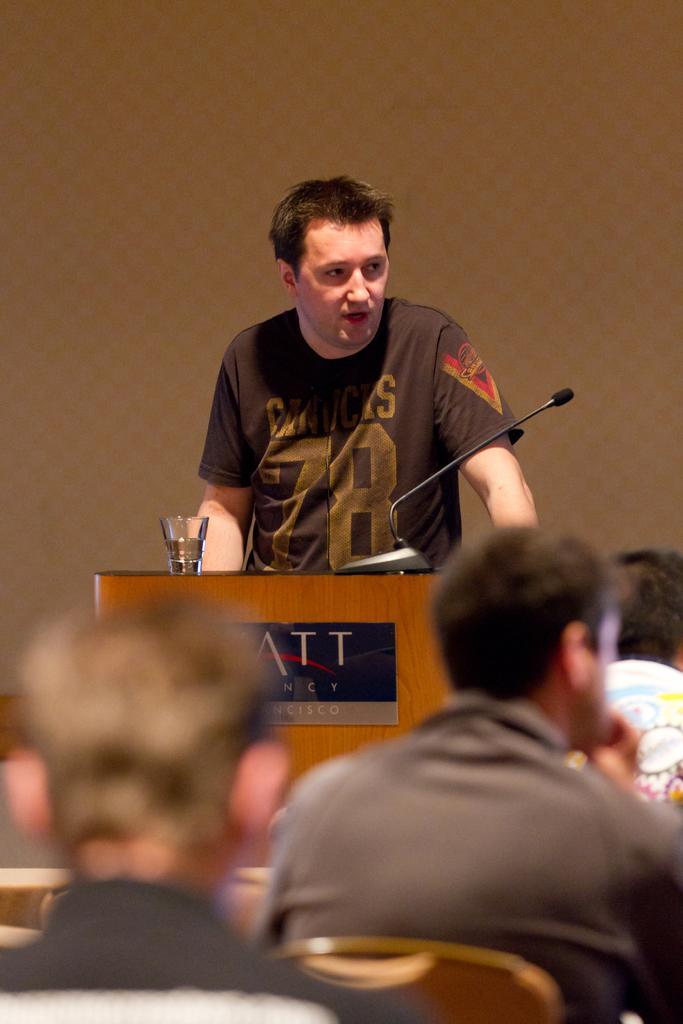Please provide a concise description of this image. Background portion of the picture is in brown color. In this picture we can see a man wearing a t-shirt and he is standing. On the podium we can see a microphone, glass of water. We can see a board. In this picture we can see the people sitting on the chairs. 